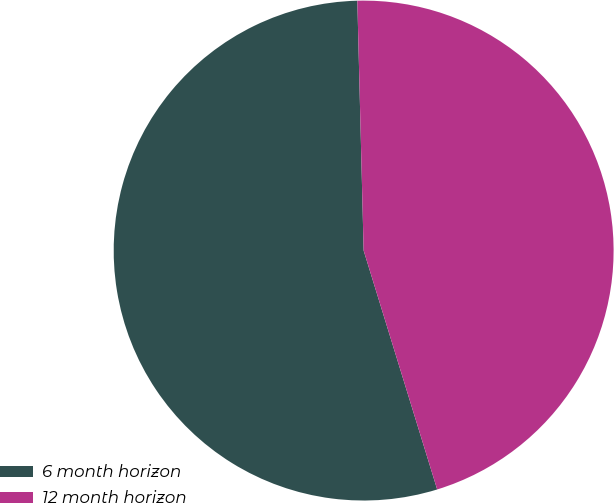Convert chart. <chart><loc_0><loc_0><loc_500><loc_500><pie_chart><fcel>6 month horizon<fcel>12 month horizon<nl><fcel>54.35%<fcel>45.65%<nl></chart> 